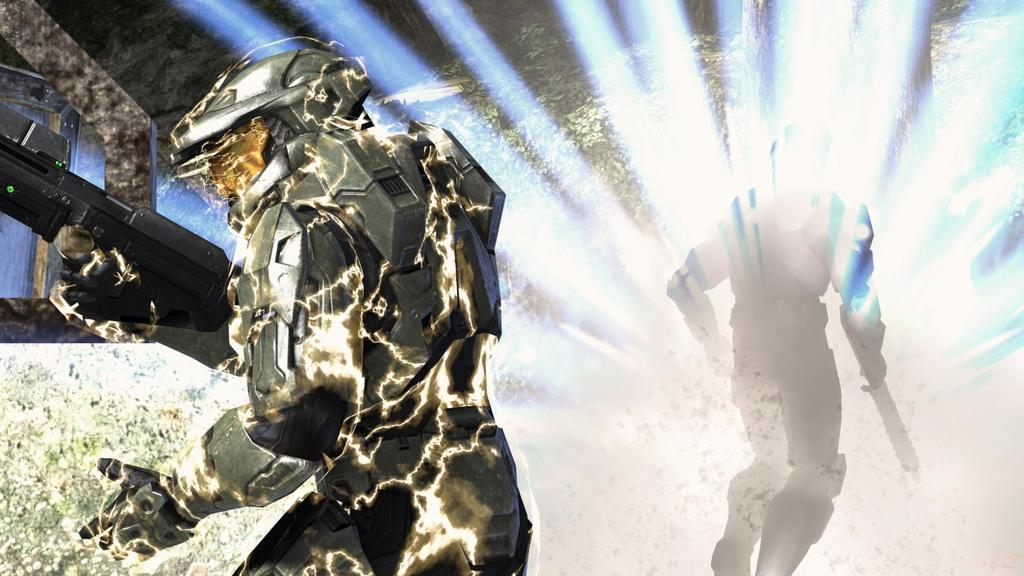What type of image is being described? The image is an animation. Where can a person's shadow be seen in the image? The person's shadow is on the right side of the image. What is the person's shadow holding? The person's shadow is holding an object. Can you describe the person on the left side of the image? The person on the left is holding a gun. What is visible in the background of the image? There is a wall in the background of the image. How many waves can be seen crashing against the shore in the image? There are no waves present in the image; it is an animation featuring a person's shadow and a person holding a gun. What type of twig is the person on the left side of the image using as a weapon? There is no twig present in the image; the person on the left is holding a gun. 